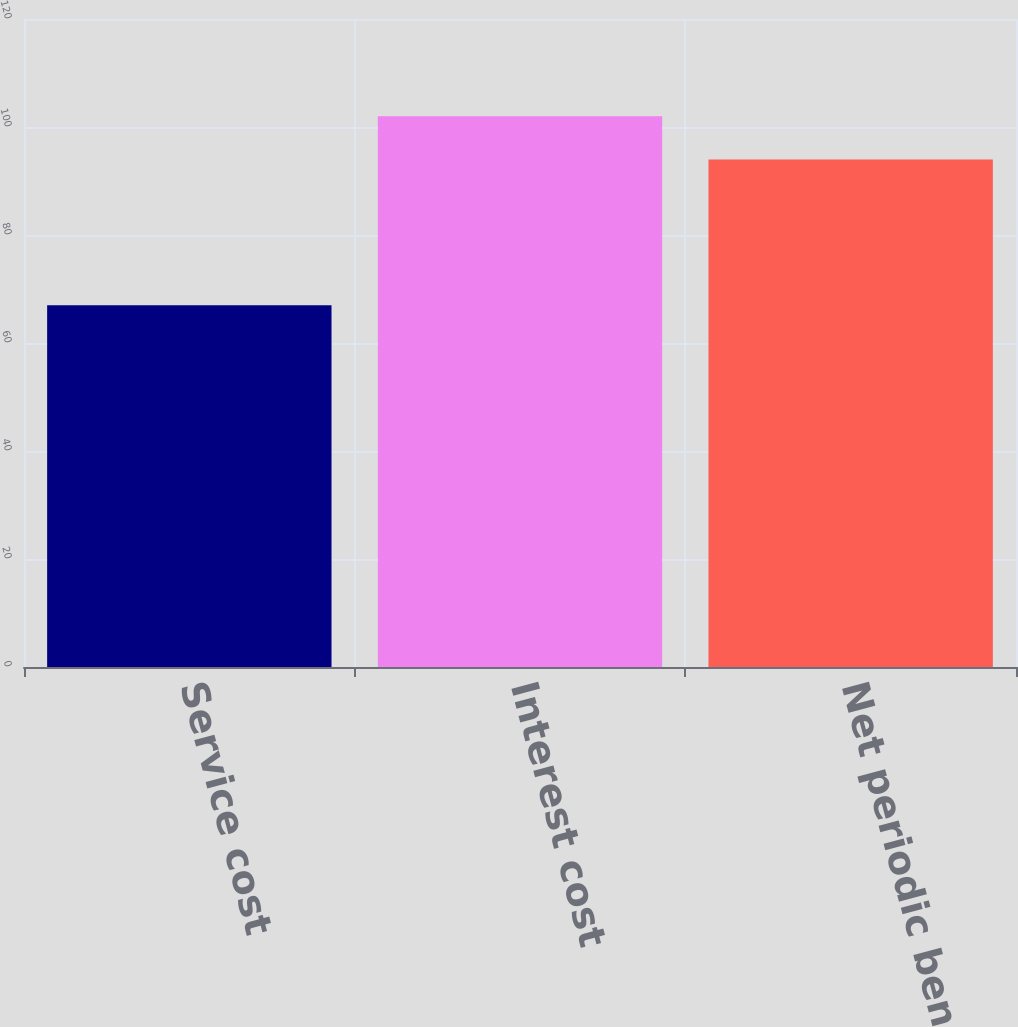Convert chart. <chart><loc_0><loc_0><loc_500><loc_500><bar_chart><fcel>Service cost<fcel>Interest cost<fcel>Net periodic benefit cost<nl><fcel>67<fcel>102<fcel>94<nl></chart> 